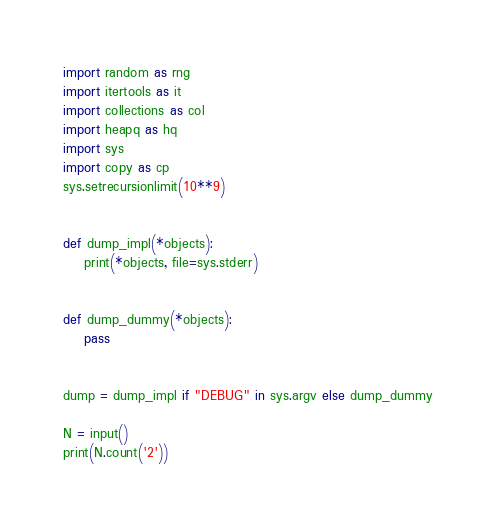Convert code to text. <code><loc_0><loc_0><loc_500><loc_500><_Python_>import random as rng
import itertools as it
import collections as col
import heapq as hq
import sys
import copy as cp
sys.setrecursionlimit(10**9)


def dump_impl(*objects):
    print(*objects, file=sys.stderr)


def dump_dummy(*objects):
    pass


dump = dump_impl if "DEBUG" in sys.argv else dump_dummy

N = input()
print(N.count('2'))
</code> 